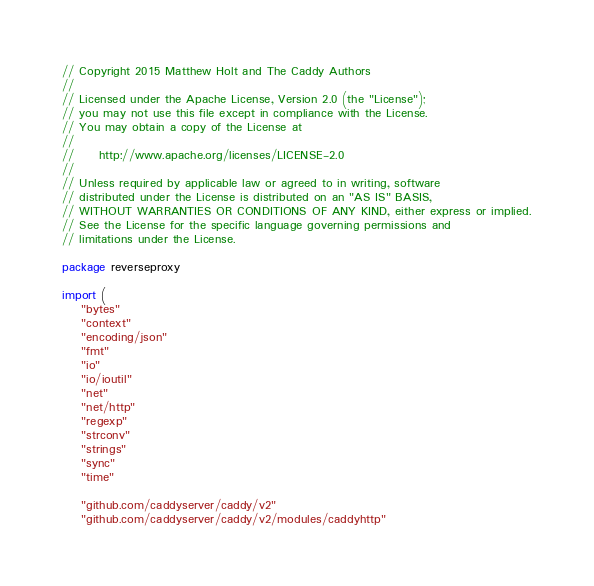Convert code to text. <code><loc_0><loc_0><loc_500><loc_500><_Go_>// Copyright 2015 Matthew Holt and The Caddy Authors
//
// Licensed under the Apache License, Version 2.0 (the "License");
// you may not use this file except in compliance with the License.
// You may obtain a copy of the License at
//
//     http://www.apache.org/licenses/LICENSE-2.0
//
// Unless required by applicable law or agreed to in writing, software
// distributed under the License is distributed on an "AS IS" BASIS,
// WITHOUT WARRANTIES OR CONDITIONS OF ANY KIND, either express or implied.
// See the License for the specific language governing permissions and
// limitations under the License.

package reverseproxy

import (
	"bytes"
	"context"
	"encoding/json"
	"fmt"
	"io"
	"io/ioutil"
	"net"
	"net/http"
	"regexp"
	"strconv"
	"strings"
	"sync"
	"time"

	"github.com/caddyserver/caddy/v2"
	"github.com/caddyserver/caddy/v2/modules/caddyhttp"</code> 